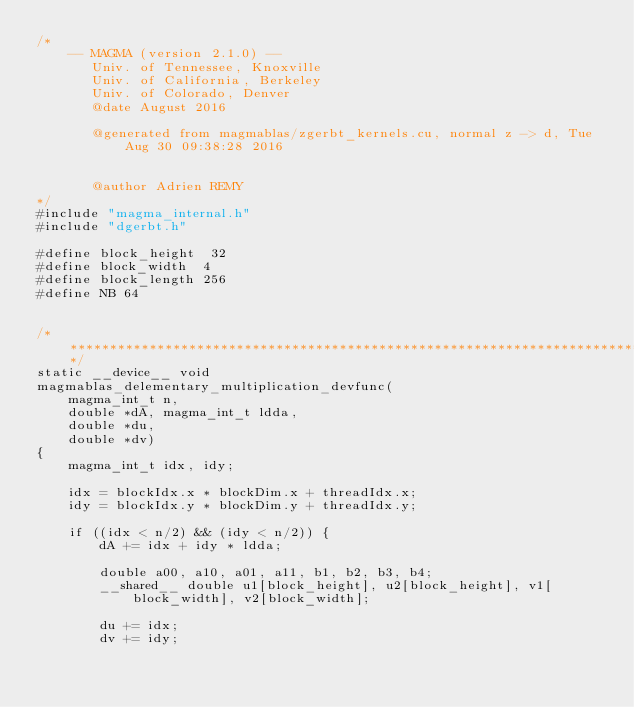<code> <loc_0><loc_0><loc_500><loc_500><_Cuda_>/*
    -- MAGMA (version 2.1.0) --
       Univ. of Tennessee, Knoxville
       Univ. of California, Berkeley
       Univ. of Colorado, Denver
       @date August 2016

       @generated from magmablas/zgerbt_kernels.cu, normal z -> d, Tue Aug 30 09:38:28 2016


       @author Adrien REMY
*/
#include "magma_internal.h"
#include "dgerbt.h"

#define block_height  32
#define block_width  4
#define block_length 256
#define NB 64


/******************************************************************************/
static __device__ void 
magmablas_delementary_multiplication_devfunc(
    magma_int_t n,
    double *dA, magma_int_t ldda, 
    double *du, 
    double *dv)
{    
    magma_int_t idx, idy;

    idx = blockIdx.x * blockDim.x + threadIdx.x;
    idy = blockIdx.y * blockDim.y + threadIdx.y;

    if ((idx < n/2) && (idy < n/2)) {
        dA += idx + idy * ldda;

        double a00, a10, a01, a11, b1, b2, b3, b4;
        __shared__ double u1[block_height], u2[block_height], v1[block_width], v2[block_width];

        du += idx;
        dv += idy;
</code> 